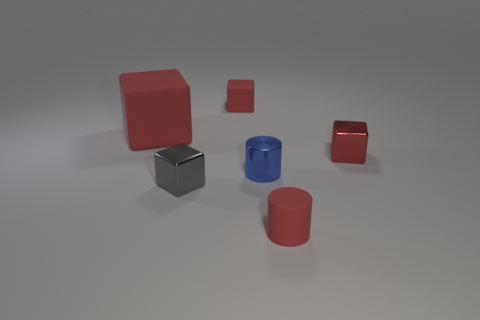Subtract all cyan spheres. How many red blocks are left? 3 Add 3 brown blocks. How many objects exist? 9 Subtract all cubes. How many objects are left? 2 Subtract all big red blocks. Subtract all big purple shiny cubes. How many objects are left? 5 Add 2 tiny metallic cubes. How many tiny metallic cubes are left? 4 Add 1 tiny red balls. How many tiny red balls exist? 1 Subtract 2 red cubes. How many objects are left? 4 